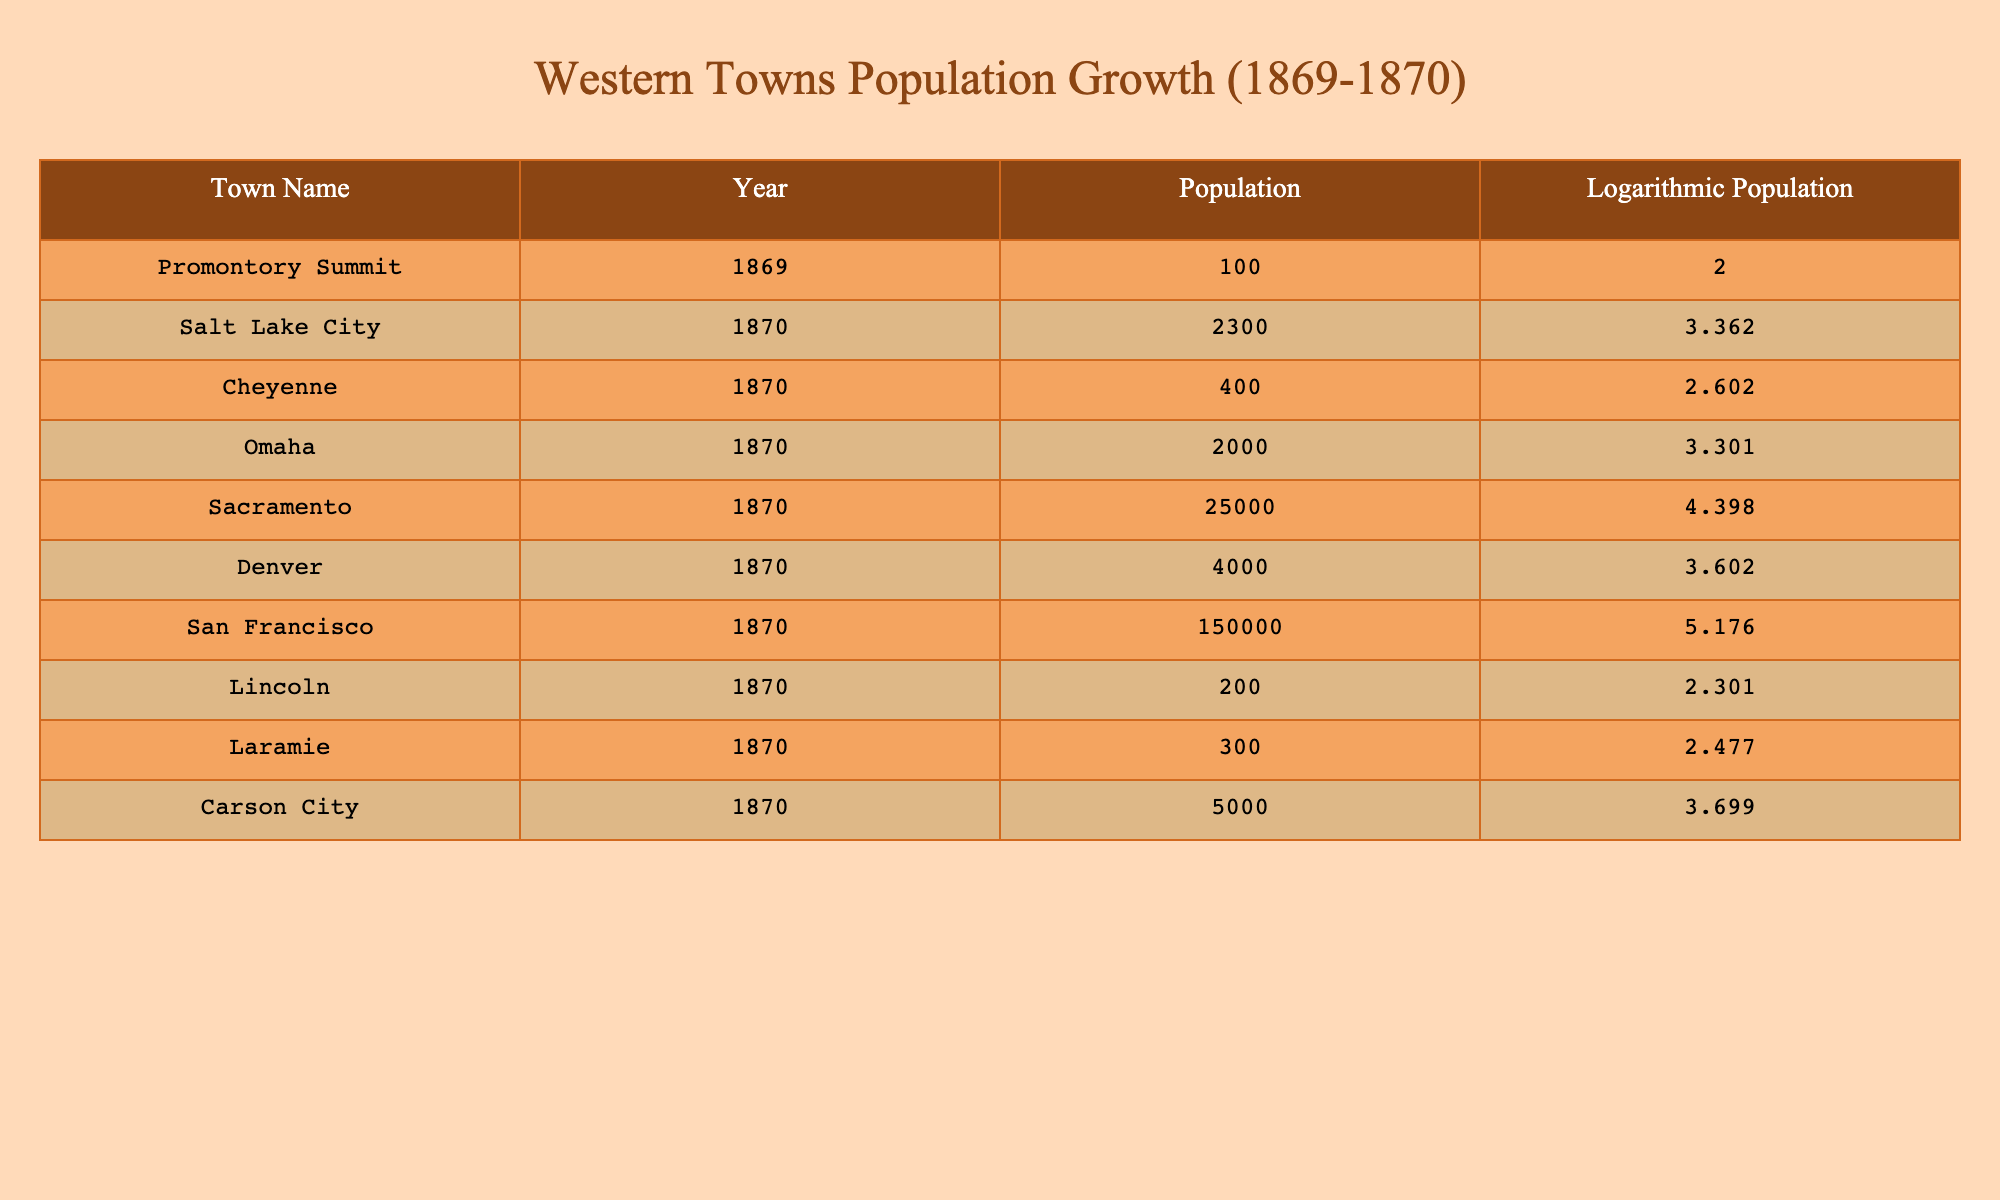What is the population of San Francisco in 1870? The table indicates that the population of San Francisco in 1870 is listed directly in the Population column. By locating the row corresponding to San Francisco, we find that it shows a population of 150,000.
Answer: 150000 Which town had a population closest to 500 in 1870? By examining the Population column, we look for values that are near 500. The towns listed are Cheyenne with 400, Laramie with 300, and Carson City with 5000. Therefore, Cheyenne at 400 is the closest to 500.
Answer: Cheyenne Calculate the difference in population between Sacramento and Omaha in 1870. To find this difference, we first look at the populations from the Population column, obtaining Sacramento's population of 25,000 and Omaha's population of 2,000. The difference is calculated by subtracting 2,000 from 25,000. This gives us 25,000 - 2,000 = 23,000.
Answer: 23000 Is the logarithmic population of Denver higher than that of Omaha in 1870? The logarithmic populations from the Logarithmic Population column show that Denver has a logarithmic population of 3.602, whereas Omaha has a logarithmic population of 3.301. Since 3.602 is greater than 3.301, the statement is true.
Answer: Yes What is the average population of the towns listed in the table for 1870? To find the average, we need to sum all the populations: (2300 + 400 + 2000 + 25000 + 4000 + 150000 + 200 + 300 + 5000) = 181,200. There are 8 towns listed, so the average population is 181,200 divided by 8, which equals 22,650.
Answer: 22650 